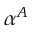<formula> <loc_0><loc_0><loc_500><loc_500>\alpha ^ { A }</formula> 